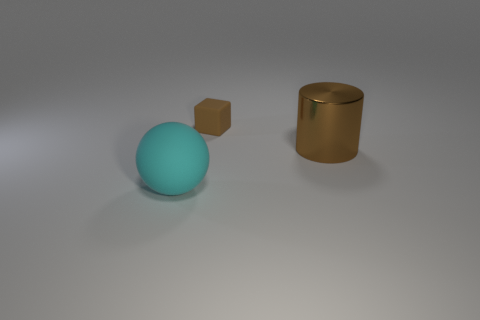Add 3 tiny yellow cylinders. How many objects exist? 6 Subtract all cylinders. How many objects are left? 2 Add 2 big shiny cylinders. How many big shiny cylinders exist? 3 Subtract 0 purple blocks. How many objects are left? 3 Subtract all cyan rubber objects. Subtract all tiny brown things. How many objects are left? 1 Add 2 large shiny cylinders. How many large shiny cylinders are left? 3 